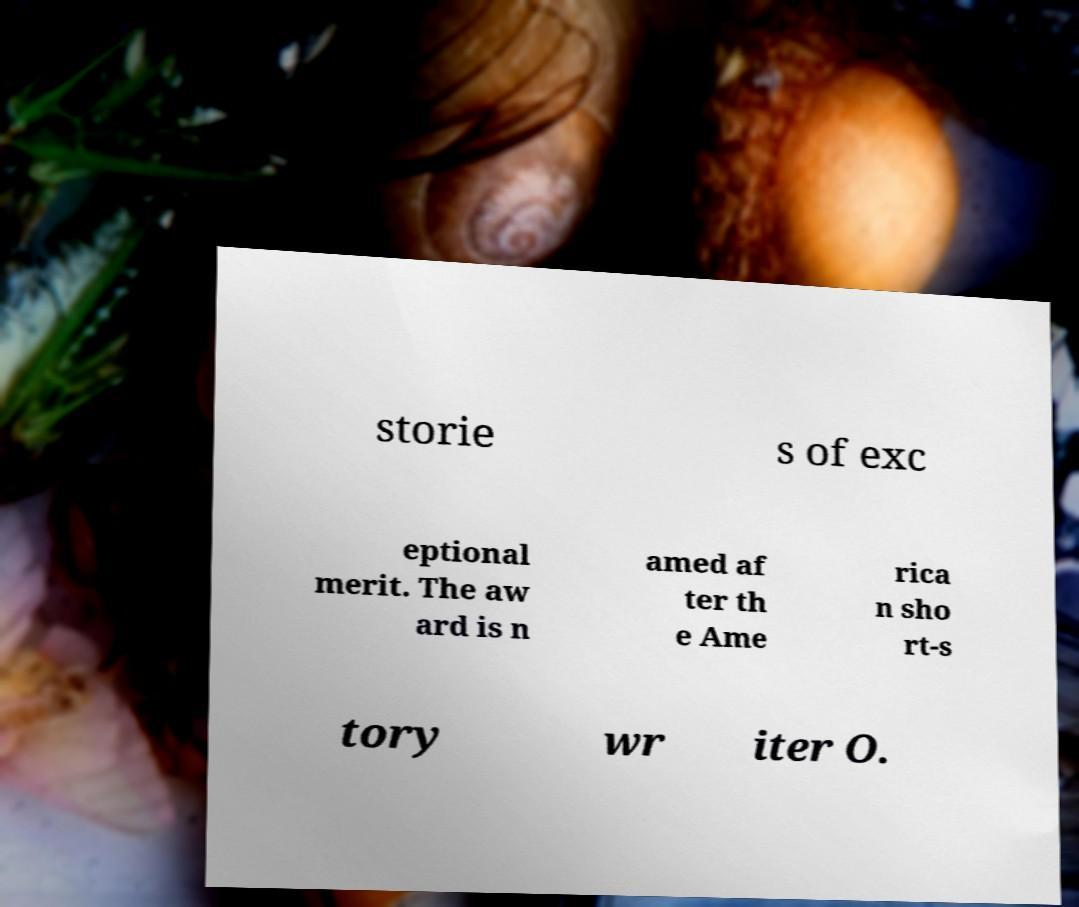For documentation purposes, I need the text within this image transcribed. Could you provide that? storie s of exc eptional merit. The aw ard is n amed af ter th e Ame rica n sho rt-s tory wr iter O. 